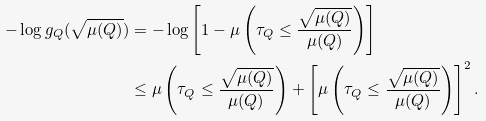Convert formula to latex. <formula><loc_0><loc_0><loc_500><loc_500>- \log g _ { Q } ( \sqrt { \mu ( Q ) } ) & = - \log \left [ 1 - \mu \left ( \tau _ { Q } \leq \frac { \sqrt { \mu ( Q ) } } { \mu ( Q ) } \right ) \right ] \\ & \leq \mu \left ( \tau _ { Q } \leq \frac { \sqrt { \mu ( Q ) } } { \mu ( Q ) } \right ) + \left [ \mu \left ( \tau _ { Q } \leq \frac { \sqrt { \mu ( Q ) } } { \mu ( Q ) } \right ) \right ] ^ { 2 } .</formula> 